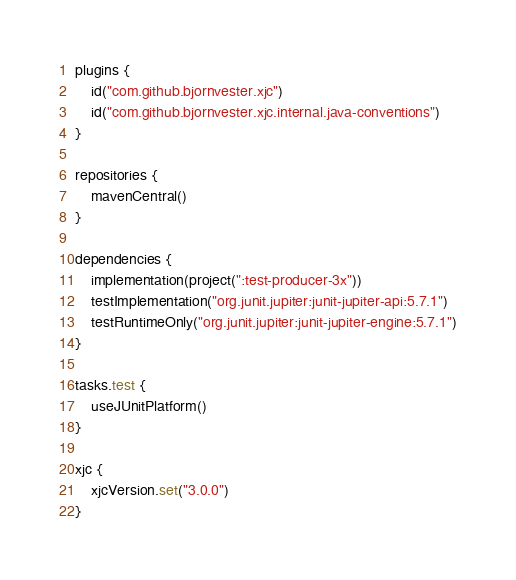Convert code to text. <code><loc_0><loc_0><loc_500><loc_500><_Kotlin_>plugins {
    id("com.github.bjornvester.xjc")
    id("com.github.bjornvester.xjc.internal.java-conventions")
}

repositories {
    mavenCentral()
}

dependencies {
    implementation(project(":test-producer-3x"))
    testImplementation("org.junit.jupiter:junit-jupiter-api:5.7.1")
    testRuntimeOnly("org.junit.jupiter:junit-jupiter-engine:5.7.1")
}

tasks.test {
    useJUnitPlatform()
}

xjc {
    xjcVersion.set("3.0.0")
}
</code> 